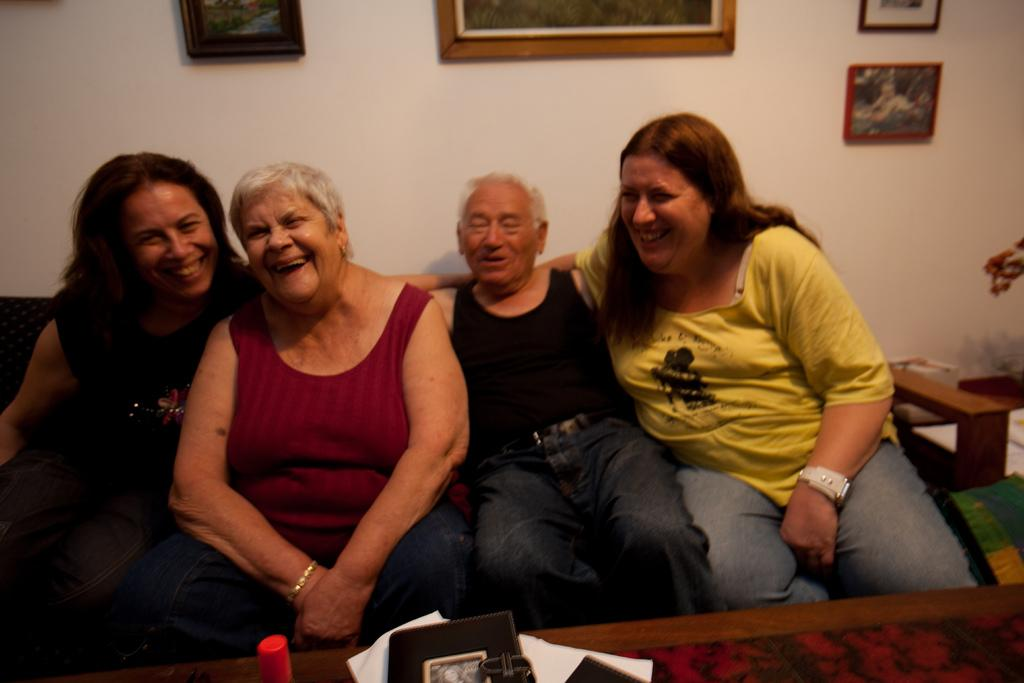How many people are in the image? There are four persons in the image. What are the persons doing in the image? The persons are sitting on a sofa and smiling. What can be seen on the table in the image? There is a book and papers on the table. What is visible on the wall in the background? There are frames on the wall in the background. What type of cover is being used to protect the sofa in the image? There is no mention of a cover being used to protect the sofa in the image. 